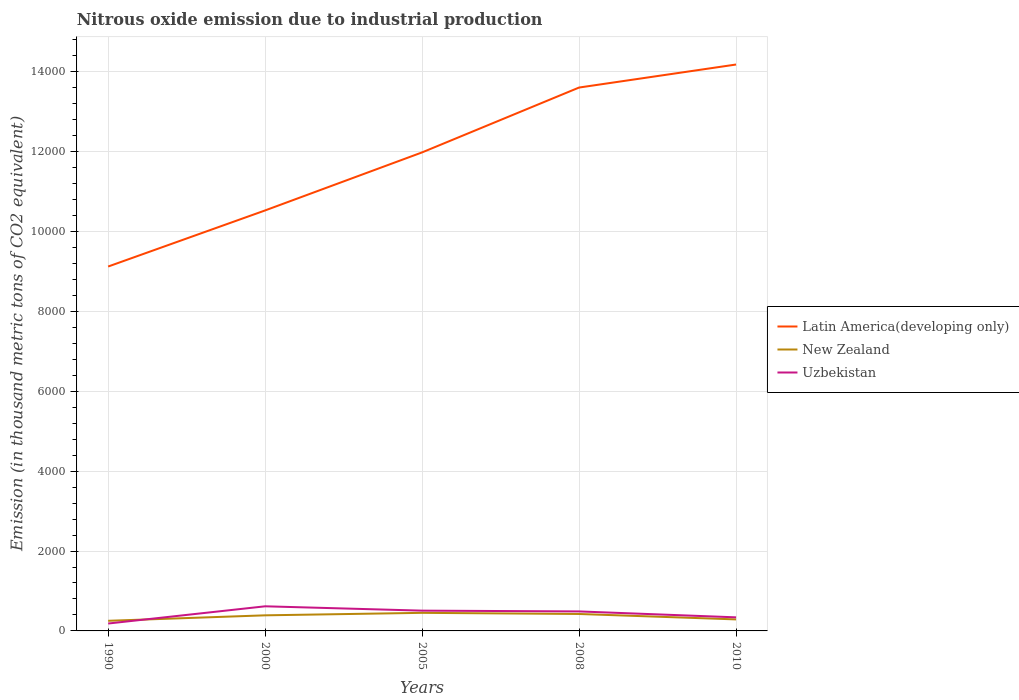How many different coloured lines are there?
Offer a terse response. 3. Does the line corresponding to Latin America(developing only) intersect with the line corresponding to Uzbekistan?
Your response must be concise. No. Across all years, what is the maximum amount of nitrous oxide emitted in New Zealand?
Provide a succinct answer. 253.4. In which year was the amount of nitrous oxide emitted in Uzbekistan maximum?
Your answer should be very brief. 1990. What is the total amount of nitrous oxide emitted in Uzbekistan in the graph?
Your response must be concise. -431.3. What is the difference between the highest and the second highest amount of nitrous oxide emitted in Uzbekistan?
Keep it short and to the point. 431.3. How many years are there in the graph?
Offer a terse response. 5. What is the difference between two consecutive major ticks on the Y-axis?
Provide a short and direct response. 2000. Are the values on the major ticks of Y-axis written in scientific E-notation?
Keep it short and to the point. No. Does the graph contain any zero values?
Offer a terse response. No. Does the graph contain grids?
Your answer should be very brief. Yes. Where does the legend appear in the graph?
Offer a very short reply. Center right. What is the title of the graph?
Give a very brief answer. Nitrous oxide emission due to industrial production. Does "Jamaica" appear as one of the legend labels in the graph?
Provide a succinct answer. No. What is the label or title of the X-axis?
Your answer should be compact. Years. What is the label or title of the Y-axis?
Offer a terse response. Emission (in thousand metric tons of CO2 equivalent). What is the Emission (in thousand metric tons of CO2 equivalent) in Latin America(developing only) in 1990?
Your response must be concise. 9123.8. What is the Emission (in thousand metric tons of CO2 equivalent) of New Zealand in 1990?
Keep it short and to the point. 253.4. What is the Emission (in thousand metric tons of CO2 equivalent) of Uzbekistan in 1990?
Your answer should be compact. 185.1. What is the Emission (in thousand metric tons of CO2 equivalent) in Latin America(developing only) in 2000?
Provide a succinct answer. 1.05e+04. What is the Emission (in thousand metric tons of CO2 equivalent) in New Zealand in 2000?
Offer a terse response. 390.5. What is the Emission (in thousand metric tons of CO2 equivalent) of Uzbekistan in 2000?
Make the answer very short. 616.4. What is the Emission (in thousand metric tons of CO2 equivalent) of Latin America(developing only) in 2005?
Offer a terse response. 1.20e+04. What is the Emission (in thousand metric tons of CO2 equivalent) in New Zealand in 2005?
Keep it short and to the point. 452.7. What is the Emission (in thousand metric tons of CO2 equivalent) of Uzbekistan in 2005?
Your answer should be very brief. 507.8. What is the Emission (in thousand metric tons of CO2 equivalent) of Latin America(developing only) in 2008?
Keep it short and to the point. 1.36e+04. What is the Emission (in thousand metric tons of CO2 equivalent) in New Zealand in 2008?
Ensure brevity in your answer.  424. What is the Emission (in thousand metric tons of CO2 equivalent) in Uzbekistan in 2008?
Your answer should be compact. 488.2. What is the Emission (in thousand metric tons of CO2 equivalent) of Latin America(developing only) in 2010?
Offer a terse response. 1.42e+04. What is the Emission (in thousand metric tons of CO2 equivalent) of New Zealand in 2010?
Your response must be concise. 288.3. What is the Emission (in thousand metric tons of CO2 equivalent) in Uzbekistan in 2010?
Offer a terse response. 340. Across all years, what is the maximum Emission (in thousand metric tons of CO2 equivalent) of Latin America(developing only)?
Your answer should be very brief. 1.42e+04. Across all years, what is the maximum Emission (in thousand metric tons of CO2 equivalent) of New Zealand?
Provide a short and direct response. 452.7. Across all years, what is the maximum Emission (in thousand metric tons of CO2 equivalent) in Uzbekistan?
Offer a terse response. 616.4. Across all years, what is the minimum Emission (in thousand metric tons of CO2 equivalent) of Latin America(developing only)?
Your response must be concise. 9123.8. Across all years, what is the minimum Emission (in thousand metric tons of CO2 equivalent) in New Zealand?
Make the answer very short. 253.4. Across all years, what is the minimum Emission (in thousand metric tons of CO2 equivalent) in Uzbekistan?
Your answer should be compact. 185.1. What is the total Emission (in thousand metric tons of CO2 equivalent) in Latin America(developing only) in the graph?
Your response must be concise. 5.94e+04. What is the total Emission (in thousand metric tons of CO2 equivalent) of New Zealand in the graph?
Keep it short and to the point. 1808.9. What is the total Emission (in thousand metric tons of CO2 equivalent) in Uzbekistan in the graph?
Your response must be concise. 2137.5. What is the difference between the Emission (in thousand metric tons of CO2 equivalent) in Latin America(developing only) in 1990 and that in 2000?
Keep it short and to the point. -1404.8. What is the difference between the Emission (in thousand metric tons of CO2 equivalent) in New Zealand in 1990 and that in 2000?
Your answer should be compact. -137.1. What is the difference between the Emission (in thousand metric tons of CO2 equivalent) in Uzbekistan in 1990 and that in 2000?
Give a very brief answer. -431.3. What is the difference between the Emission (in thousand metric tons of CO2 equivalent) of Latin America(developing only) in 1990 and that in 2005?
Your answer should be very brief. -2858. What is the difference between the Emission (in thousand metric tons of CO2 equivalent) of New Zealand in 1990 and that in 2005?
Give a very brief answer. -199.3. What is the difference between the Emission (in thousand metric tons of CO2 equivalent) in Uzbekistan in 1990 and that in 2005?
Offer a very short reply. -322.7. What is the difference between the Emission (in thousand metric tons of CO2 equivalent) of Latin America(developing only) in 1990 and that in 2008?
Provide a short and direct response. -4481.8. What is the difference between the Emission (in thousand metric tons of CO2 equivalent) of New Zealand in 1990 and that in 2008?
Your response must be concise. -170.6. What is the difference between the Emission (in thousand metric tons of CO2 equivalent) in Uzbekistan in 1990 and that in 2008?
Give a very brief answer. -303.1. What is the difference between the Emission (in thousand metric tons of CO2 equivalent) of Latin America(developing only) in 1990 and that in 2010?
Keep it short and to the point. -5058. What is the difference between the Emission (in thousand metric tons of CO2 equivalent) in New Zealand in 1990 and that in 2010?
Provide a succinct answer. -34.9. What is the difference between the Emission (in thousand metric tons of CO2 equivalent) in Uzbekistan in 1990 and that in 2010?
Ensure brevity in your answer.  -154.9. What is the difference between the Emission (in thousand metric tons of CO2 equivalent) of Latin America(developing only) in 2000 and that in 2005?
Provide a short and direct response. -1453.2. What is the difference between the Emission (in thousand metric tons of CO2 equivalent) in New Zealand in 2000 and that in 2005?
Keep it short and to the point. -62.2. What is the difference between the Emission (in thousand metric tons of CO2 equivalent) in Uzbekistan in 2000 and that in 2005?
Provide a succinct answer. 108.6. What is the difference between the Emission (in thousand metric tons of CO2 equivalent) in Latin America(developing only) in 2000 and that in 2008?
Provide a succinct answer. -3077. What is the difference between the Emission (in thousand metric tons of CO2 equivalent) in New Zealand in 2000 and that in 2008?
Your answer should be compact. -33.5. What is the difference between the Emission (in thousand metric tons of CO2 equivalent) of Uzbekistan in 2000 and that in 2008?
Keep it short and to the point. 128.2. What is the difference between the Emission (in thousand metric tons of CO2 equivalent) in Latin America(developing only) in 2000 and that in 2010?
Your answer should be compact. -3653.2. What is the difference between the Emission (in thousand metric tons of CO2 equivalent) of New Zealand in 2000 and that in 2010?
Offer a very short reply. 102.2. What is the difference between the Emission (in thousand metric tons of CO2 equivalent) of Uzbekistan in 2000 and that in 2010?
Offer a terse response. 276.4. What is the difference between the Emission (in thousand metric tons of CO2 equivalent) in Latin America(developing only) in 2005 and that in 2008?
Give a very brief answer. -1623.8. What is the difference between the Emission (in thousand metric tons of CO2 equivalent) in New Zealand in 2005 and that in 2008?
Your response must be concise. 28.7. What is the difference between the Emission (in thousand metric tons of CO2 equivalent) in Uzbekistan in 2005 and that in 2008?
Keep it short and to the point. 19.6. What is the difference between the Emission (in thousand metric tons of CO2 equivalent) of Latin America(developing only) in 2005 and that in 2010?
Offer a very short reply. -2200. What is the difference between the Emission (in thousand metric tons of CO2 equivalent) in New Zealand in 2005 and that in 2010?
Give a very brief answer. 164.4. What is the difference between the Emission (in thousand metric tons of CO2 equivalent) in Uzbekistan in 2005 and that in 2010?
Provide a short and direct response. 167.8. What is the difference between the Emission (in thousand metric tons of CO2 equivalent) in Latin America(developing only) in 2008 and that in 2010?
Keep it short and to the point. -576.2. What is the difference between the Emission (in thousand metric tons of CO2 equivalent) of New Zealand in 2008 and that in 2010?
Your answer should be very brief. 135.7. What is the difference between the Emission (in thousand metric tons of CO2 equivalent) in Uzbekistan in 2008 and that in 2010?
Make the answer very short. 148.2. What is the difference between the Emission (in thousand metric tons of CO2 equivalent) in Latin America(developing only) in 1990 and the Emission (in thousand metric tons of CO2 equivalent) in New Zealand in 2000?
Ensure brevity in your answer.  8733.3. What is the difference between the Emission (in thousand metric tons of CO2 equivalent) in Latin America(developing only) in 1990 and the Emission (in thousand metric tons of CO2 equivalent) in Uzbekistan in 2000?
Provide a succinct answer. 8507.4. What is the difference between the Emission (in thousand metric tons of CO2 equivalent) of New Zealand in 1990 and the Emission (in thousand metric tons of CO2 equivalent) of Uzbekistan in 2000?
Offer a very short reply. -363. What is the difference between the Emission (in thousand metric tons of CO2 equivalent) of Latin America(developing only) in 1990 and the Emission (in thousand metric tons of CO2 equivalent) of New Zealand in 2005?
Your answer should be very brief. 8671.1. What is the difference between the Emission (in thousand metric tons of CO2 equivalent) of Latin America(developing only) in 1990 and the Emission (in thousand metric tons of CO2 equivalent) of Uzbekistan in 2005?
Offer a terse response. 8616. What is the difference between the Emission (in thousand metric tons of CO2 equivalent) in New Zealand in 1990 and the Emission (in thousand metric tons of CO2 equivalent) in Uzbekistan in 2005?
Offer a terse response. -254.4. What is the difference between the Emission (in thousand metric tons of CO2 equivalent) in Latin America(developing only) in 1990 and the Emission (in thousand metric tons of CO2 equivalent) in New Zealand in 2008?
Offer a very short reply. 8699.8. What is the difference between the Emission (in thousand metric tons of CO2 equivalent) of Latin America(developing only) in 1990 and the Emission (in thousand metric tons of CO2 equivalent) of Uzbekistan in 2008?
Your answer should be compact. 8635.6. What is the difference between the Emission (in thousand metric tons of CO2 equivalent) of New Zealand in 1990 and the Emission (in thousand metric tons of CO2 equivalent) of Uzbekistan in 2008?
Your answer should be very brief. -234.8. What is the difference between the Emission (in thousand metric tons of CO2 equivalent) of Latin America(developing only) in 1990 and the Emission (in thousand metric tons of CO2 equivalent) of New Zealand in 2010?
Keep it short and to the point. 8835.5. What is the difference between the Emission (in thousand metric tons of CO2 equivalent) of Latin America(developing only) in 1990 and the Emission (in thousand metric tons of CO2 equivalent) of Uzbekistan in 2010?
Ensure brevity in your answer.  8783.8. What is the difference between the Emission (in thousand metric tons of CO2 equivalent) of New Zealand in 1990 and the Emission (in thousand metric tons of CO2 equivalent) of Uzbekistan in 2010?
Offer a very short reply. -86.6. What is the difference between the Emission (in thousand metric tons of CO2 equivalent) in Latin America(developing only) in 2000 and the Emission (in thousand metric tons of CO2 equivalent) in New Zealand in 2005?
Keep it short and to the point. 1.01e+04. What is the difference between the Emission (in thousand metric tons of CO2 equivalent) in Latin America(developing only) in 2000 and the Emission (in thousand metric tons of CO2 equivalent) in Uzbekistan in 2005?
Offer a very short reply. 1.00e+04. What is the difference between the Emission (in thousand metric tons of CO2 equivalent) of New Zealand in 2000 and the Emission (in thousand metric tons of CO2 equivalent) of Uzbekistan in 2005?
Your response must be concise. -117.3. What is the difference between the Emission (in thousand metric tons of CO2 equivalent) in Latin America(developing only) in 2000 and the Emission (in thousand metric tons of CO2 equivalent) in New Zealand in 2008?
Make the answer very short. 1.01e+04. What is the difference between the Emission (in thousand metric tons of CO2 equivalent) in Latin America(developing only) in 2000 and the Emission (in thousand metric tons of CO2 equivalent) in Uzbekistan in 2008?
Offer a very short reply. 1.00e+04. What is the difference between the Emission (in thousand metric tons of CO2 equivalent) of New Zealand in 2000 and the Emission (in thousand metric tons of CO2 equivalent) of Uzbekistan in 2008?
Make the answer very short. -97.7. What is the difference between the Emission (in thousand metric tons of CO2 equivalent) of Latin America(developing only) in 2000 and the Emission (in thousand metric tons of CO2 equivalent) of New Zealand in 2010?
Make the answer very short. 1.02e+04. What is the difference between the Emission (in thousand metric tons of CO2 equivalent) of Latin America(developing only) in 2000 and the Emission (in thousand metric tons of CO2 equivalent) of Uzbekistan in 2010?
Provide a short and direct response. 1.02e+04. What is the difference between the Emission (in thousand metric tons of CO2 equivalent) of New Zealand in 2000 and the Emission (in thousand metric tons of CO2 equivalent) of Uzbekistan in 2010?
Give a very brief answer. 50.5. What is the difference between the Emission (in thousand metric tons of CO2 equivalent) in Latin America(developing only) in 2005 and the Emission (in thousand metric tons of CO2 equivalent) in New Zealand in 2008?
Ensure brevity in your answer.  1.16e+04. What is the difference between the Emission (in thousand metric tons of CO2 equivalent) in Latin America(developing only) in 2005 and the Emission (in thousand metric tons of CO2 equivalent) in Uzbekistan in 2008?
Make the answer very short. 1.15e+04. What is the difference between the Emission (in thousand metric tons of CO2 equivalent) in New Zealand in 2005 and the Emission (in thousand metric tons of CO2 equivalent) in Uzbekistan in 2008?
Ensure brevity in your answer.  -35.5. What is the difference between the Emission (in thousand metric tons of CO2 equivalent) in Latin America(developing only) in 2005 and the Emission (in thousand metric tons of CO2 equivalent) in New Zealand in 2010?
Make the answer very short. 1.17e+04. What is the difference between the Emission (in thousand metric tons of CO2 equivalent) of Latin America(developing only) in 2005 and the Emission (in thousand metric tons of CO2 equivalent) of Uzbekistan in 2010?
Offer a terse response. 1.16e+04. What is the difference between the Emission (in thousand metric tons of CO2 equivalent) of New Zealand in 2005 and the Emission (in thousand metric tons of CO2 equivalent) of Uzbekistan in 2010?
Offer a terse response. 112.7. What is the difference between the Emission (in thousand metric tons of CO2 equivalent) in Latin America(developing only) in 2008 and the Emission (in thousand metric tons of CO2 equivalent) in New Zealand in 2010?
Give a very brief answer. 1.33e+04. What is the difference between the Emission (in thousand metric tons of CO2 equivalent) in Latin America(developing only) in 2008 and the Emission (in thousand metric tons of CO2 equivalent) in Uzbekistan in 2010?
Give a very brief answer. 1.33e+04. What is the difference between the Emission (in thousand metric tons of CO2 equivalent) of New Zealand in 2008 and the Emission (in thousand metric tons of CO2 equivalent) of Uzbekistan in 2010?
Ensure brevity in your answer.  84. What is the average Emission (in thousand metric tons of CO2 equivalent) of Latin America(developing only) per year?
Provide a succinct answer. 1.19e+04. What is the average Emission (in thousand metric tons of CO2 equivalent) of New Zealand per year?
Make the answer very short. 361.78. What is the average Emission (in thousand metric tons of CO2 equivalent) in Uzbekistan per year?
Offer a terse response. 427.5. In the year 1990, what is the difference between the Emission (in thousand metric tons of CO2 equivalent) of Latin America(developing only) and Emission (in thousand metric tons of CO2 equivalent) of New Zealand?
Make the answer very short. 8870.4. In the year 1990, what is the difference between the Emission (in thousand metric tons of CO2 equivalent) of Latin America(developing only) and Emission (in thousand metric tons of CO2 equivalent) of Uzbekistan?
Your answer should be very brief. 8938.7. In the year 1990, what is the difference between the Emission (in thousand metric tons of CO2 equivalent) in New Zealand and Emission (in thousand metric tons of CO2 equivalent) in Uzbekistan?
Provide a short and direct response. 68.3. In the year 2000, what is the difference between the Emission (in thousand metric tons of CO2 equivalent) of Latin America(developing only) and Emission (in thousand metric tons of CO2 equivalent) of New Zealand?
Your response must be concise. 1.01e+04. In the year 2000, what is the difference between the Emission (in thousand metric tons of CO2 equivalent) in Latin America(developing only) and Emission (in thousand metric tons of CO2 equivalent) in Uzbekistan?
Give a very brief answer. 9912.2. In the year 2000, what is the difference between the Emission (in thousand metric tons of CO2 equivalent) of New Zealand and Emission (in thousand metric tons of CO2 equivalent) of Uzbekistan?
Ensure brevity in your answer.  -225.9. In the year 2005, what is the difference between the Emission (in thousand metric tons of CO2 equivalent) in Latin America(developing only) and Emission (in thousand metric tons of CO2 equivalent) in New Zealand?
Ensure brevity in your answer.  1.15e+04. In the year 2005, what is the difference between the Emission (in thousand metric tons of CO2 equivalent) in Latin America(developing only) and Emission (in thousand metric tons of CO2 equivalent) in Uzbekistan?
Offer a very short reply. 1.15e+04. In the year 2005, what is the difference between the Emission (in thousand metric tons of CO2 equivalent) of New Zealand and Emission (in thousand metric tons of CO2 equivalent) of Uzbekistan?
Provide a short and direct response. -55.1. In the year 2008, what is the difference between the Emission (in thousand metric tons of CO2 equivalent) of Latin America(developing only) and Emission (in thousand metric tons of CO2 equivalent) of New Zealand?
Your answer should be compact. 1.32e+04. In the year 2008, what is the difference between the Emission (in thousand metric tons of CO2 equivalent) of Latin America(developing only) and Emission (in thousand metric tons of CO2 equivalent) of Uzbekistan?
Your answer should be compact. 1.31e+04. In the year 2008, what is the difference between the Emission (in thousand metric tons of CO2 equivalent) of New Zealand and Emission (in thousand metric tons of CO2 equivalent) of Uzbekistan?
Provide a short and direct response. -64.2. In the year 2010, what is the difference between the Emission (in thousand metric tons of CO2 equivalent) in Latin America(developing only) and Emission (in thousand metric tons of CO2 equivalent) in New Zealand?
Give a very brief answer. 1.39e+04. In the year 2010, what is the difference between the Emission (in thousand metric tons of CO2 equivalent) in Latin America(developing only) and Emission (in thousand metric tons of CO2 equivalent) in Uzbekistan?
Ensure brevity in your answer.  1.38e+04. In the year 2010, what is the difference between the Emission (in thousand metric tons of CO2 equivalent) in New Zealand and Emission (in thousand metric tons of CO2 equivalent) in Uzbekistan?
Keep it short and to the point. -51.7. What is the ratio of the Emission (in thousand metric tons of CO2 equivalent) in Latin America(developing only) in 1990 to that in 2000?
Give a very brief answer. 0.87. What is the ratio of the Emission (in thousand metric tons of CO2 equivalent) of New Zealand in 1990 to that in 2000?
Offer a very short reply. 0.65. What is the ratio of the Emission (in thousand metric tons of CO2 equivalent) in Uzbekistan in 1990 to that in 2000?
Provide a short and direct response. 0.3. What is the ratio of the Emission (in thousand metric tons of CO2 equivalent) of Latin America(developing only) in 1990 to that in 2005?
Ensure brevity in your answer.  0.76. What is the ratio of the Emission (in thousand metric tons of CO2 equivalent) in New Zealand in 1990 to that in 2005?
Offer a terse response. 0.56. What is the ratio of the Emission (in thousand metric tons of CO2 equivalent) of Uzbekistan in 1990 to that in 2005?
Provide a succinct answer. 0.36. What is the ratio of the Emission (in thousand metric tons of CO2 equivalent) of Latin America(developing only) in 1990 to that in 2008?
Keep it short and to the point. 0.67. What is the ratio of the Emission (in thousand metric tons of CO2 equivalent) in New Zealand in 1990 to that in 2008?
Make the answer very short. 0.6. What is the ratio of the Emission (in thousand metric tons of CO2 equivalent) in Uzbekistan in 1990 to that in 2008?
Ensure brevity in your answer.  0.38. What is the ratio of the Emission (in thousand metric tons of CO2 equivalent) of Latin America(developing only) in 1990 to that in 2010?
Offer a terse response. 0.64. What is the ratio of the Emission (in thousand metric tons of CO2 equivalent) of New Zealand in 1990 to that in 2010?
Your response must be concise. 0.88. What is the ratio of the Emission (in thousand metric tons of CO2 equivalent) of Uzbekistan in 1990 to that in 2010?
Give a very brief answer. 0.54. What is the ratio of the Emission (in thousand metric tons of CO2 equivalent) of Latin America(developing only) in 2000 to that in 2005?
Your response must be concise. 0.88. What is the ratio of the Emission (in thousand metric tons of CO2 equivalent) in New Zealand in 2000 to that in 2005?
Provide a short and direct response. 0.86. What is the ratio of the Emission (in thousand metric tons of CO2 equivalent) in Uzbekistan in 2000 to that in 2005?
Your answer should be compact. 1.21. What is the ratio of the Emission (in thousand metric tons of CO2 equivalent) of Latin America(developing only) in 2000 to that in 2008?
Give a very brief answer. 0.77. What is the ratio of the Emission (in thousand metric tons of CO2 equivalent) of New Zealand in 2000 to that in 2008?
Keep it short and to the point. 0.92. What is the ratio of the Emission (in thousand metric tons of CO2 equivalent) of Uzbekistan in 2000 to that in 2008?
Provide a short and direct response. 1.26. What is the ratio of the Emission (in thousand metric tons of CO2 equivalent) of Latin America(developing only) in 2000 to that in 2010?
Provide a short and direct response. 0.74. What is the ratio of the Emission (in thousand metric tons of CO2 equivalent) in New Zealand in 2000 to that in 2010?
Keep it short and to the point. 1.35. What is the ratio of the Emission (in thousand metric tons of CO2 equivalent) in Uzbekistan in 2000 to that in 2010?
Your response must be concise. 1.81. What is the ratio of the Emission (in thousand metric tons of CO2 equivalent) in Latin America(developing only) in 2005 to that in 2008?
Your answer should be compact. 0.88. What is the ratio of the Emission (in thousand metric tons of CO2 equivalent) of New Zealand in 2005 to that in 2008?
Your answer should be compact. 1.07. What is the ratio of the Emission (in thousand metric tons of CO2 equivalent) in Uzbekistan in 2005 to that in 2008?
Your answer should be compact. 1.04. What is the ratio of the Emission (in thousand metric tons of CO2 equivalent) in Latin America(developing only) in 2005 to that in 2010?
Provide a short and direct response. 0.84. What is the ratio of the Emission (in thousand metric tons of CO2 equivalent) of New Zealand in 2005 to that in 2010?
Ensure brevity in your answer.  1.57. What is the ratio of the Emission (in thousand metric tons of CO2 equivalent) of Uzbekistan in 2005 to that in 2010?
Provide a short and direct response. 1.49. What is the ratio of the Emission (in thousand metric tons of CO2 equivalent) of Latin America(developing only) in 2008 to that in 2010?
Provide a short and direct response. 0.96. What is the ratio of the Emission (in thousand metric tons of CO2 equivalent) of New Zealand in 2008 to that in 2010?
Ensure brevity in your answer.  1.47. What is the ratio of the Emission (in thousand metric tons of CO2 equivalent) of Uzbekistan in 2008 to that in 2010?
Make the answer very short. 1.44. What is the difference between the highest and the second highest Emission (in thousand metric tons of CO2 equivalent) in Latin America(developing only)?
Give a very brief answer. 576.2. What is the difference between the highest and the second highest Emission (in thousand metric tons of CO2 equivalent) in New Zealand?
Ensure brevity in your answer.  28.7. What is the difference between the highest and the second highest Emission (in thousand metric tons of CO2 equivalent) in Uzbekistan?
Give a very brief answer. 108.6. What is the difference between the highest and the lowest Emission (in thousand metric tons of CO2 equivalent) of Latin America(developing only)?
Your answer should be compact. 5058. What is the difference between the highest and the lowest Emission (in thousand metric tons of CO2 equivalent) of New Zealand?
Provide a succinct answer. 199.3. What is the difference between the highest and the lowest Emission (in thousand metric tons of CO2 equivalent) in Uzbekistan?
Keep it short and to the point. 431.3. 